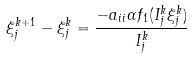Convert formula to latex. <formula><loc_0><loc_0><loc_500><loc_500>\xi _ { j } ^ { k + 1 } - \xi _ { j } ^ { k } = \frac { - a _ { i i } \alpha f _ { 1 } ( I _ { j } ^ { k } \xi _ { j } ^ { k } ) } { I _ { j } ^ { k } }</formula> 